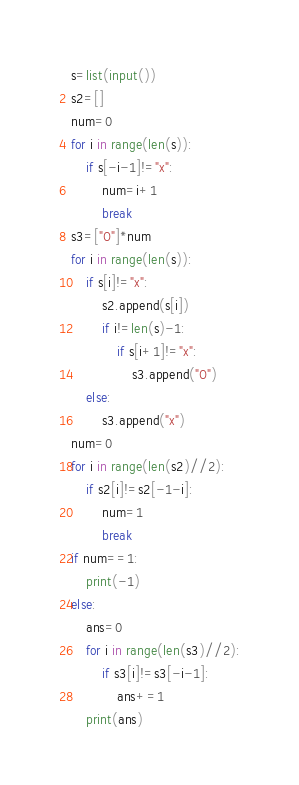Convert code to text. <code><loc_0><loc_0><loc_500><loc_500><_Python_>s=list(input())
s2=[]
num=0
for i in range(len(s)):
    if s[-i-1]!="x":
        num=i+1
        break
s3=["O"]*num
for i in range(len(s)):
    if s[i]!="x":
        s2.append(s[i])
        if i!=len(s)-1:
            if s[i+1]!="x":
                s3.append("O")
    else:
        s3.append("x")
num=0
for i in range(len(s2)//2):
    if s2[i]!=s2[-1-i]:
        num=1
        break
if num==1:
    print(-1)
else:
    ans=0
    for i in range(len(s3)//2):
        if s3[i]!=s3[-i-1]:
            ans+=1
    print(ans)
</code> 